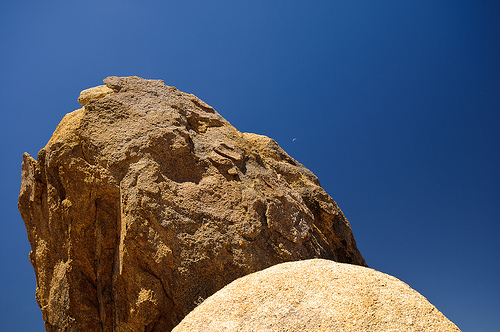<image>
Is there a sky behind the rock? Yes. From this viewpoint, the sky is positioned behind the rock, with the rock partially or fully occluding the sky. 